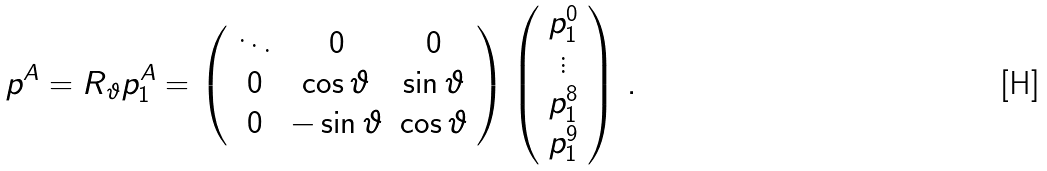Convert formula to latex. <formula><loc_0><loc_0><loc_500><loc_500>p ^ { A } = R _ { \vartheta } p _ { 1 } ^ { A } = \left ( \begin{array} { c c c } \ddots & 0 & 0 \\ 0 & \cos \vartheta & \sin \vartheta \\ 0 & - \sin \vartheta & \cos \vartheta \end{array} \right ) \left ( \begin{array} { c } p _ { 1 } ^ { 0 } \\ \vdots \\ p _ { 1 } ^ { 8 } \\ p _ { 1 } ^ { 9 } \end{array} \right ) \, .</formula> 